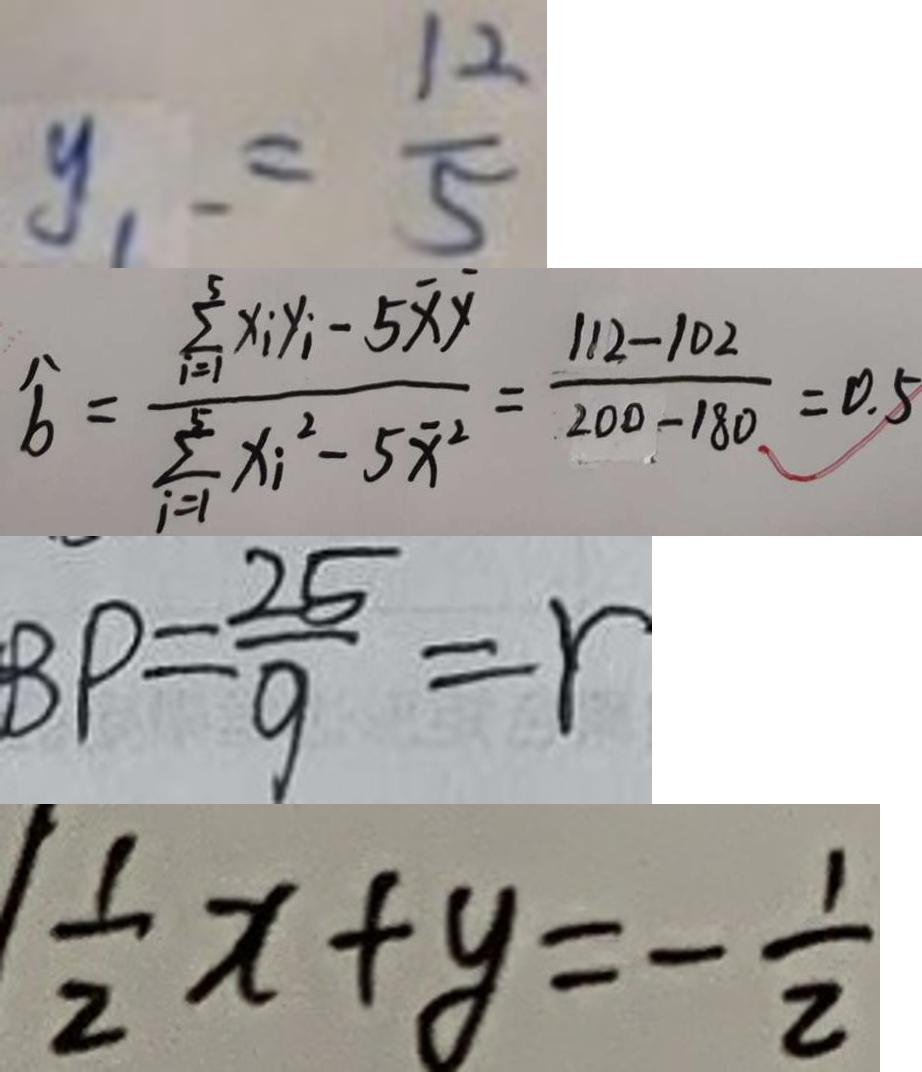<formula> <loc_0><loc_0><loc_500><loc_500>y _ { 1 } = \frac { 1 2 } { 5 } 
 \widehat { b } = \frac { \sum _ { i = 1 } ^ { 5 } x _ { i } y _ { i } - 5 \overline { x } y } { \sum _ { i = 1 } ^ { 5 } x _ { i } ^ { 2 } - 5 \overline { x } ^ { 2 } } = \frac { 1 1 2 - 1 0 2 } { 2 0 0 - 1 8 0 } = 0 . 5 
 B P = \frac { 2 5 } { 9 } = r 
 \frac { 1 } { 2 } x + y = - \frac { 1 } { 2 }</formula> 